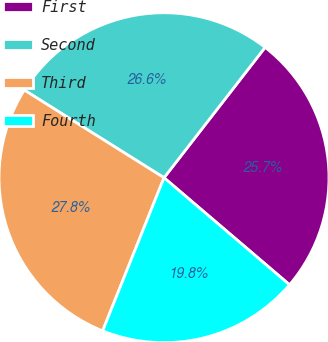<chart> <loc_0><loc_0><loc_500><loc_500><pie_chart><fcel>First<fcel>Second<fcel>Third<fcel>Fourth<nl><fcel>25.74%<fcel>26.58%<fcel>27.85%<fcel>19.83%<nl></chart> 